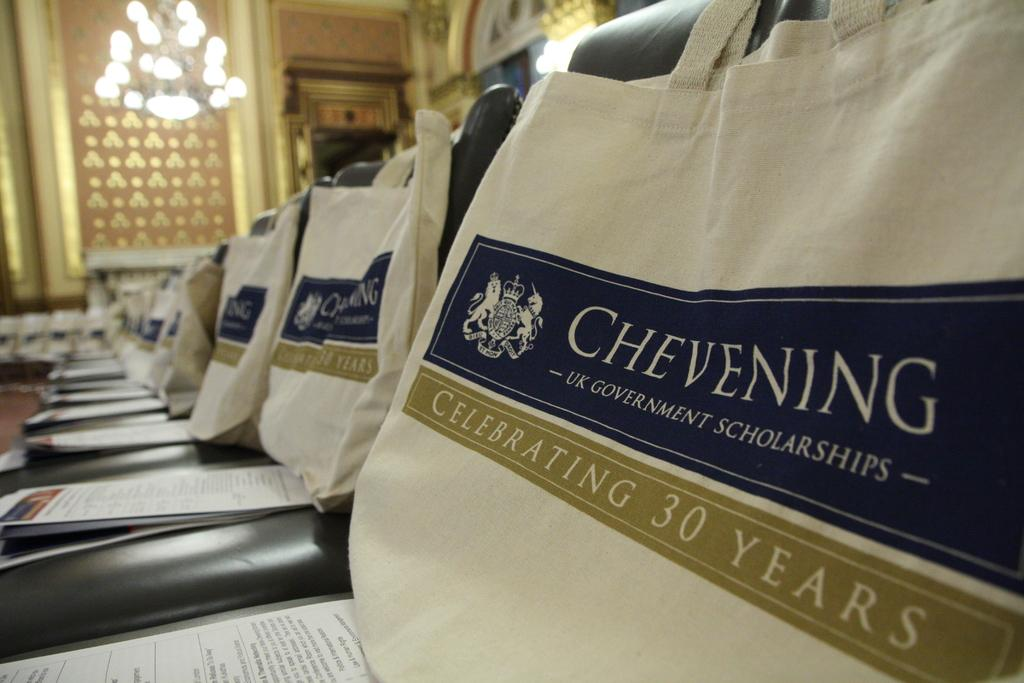<image>
Write a terse but informative summary of the picture. Chairs covered in bags for the Chevening thirty year celebration. 